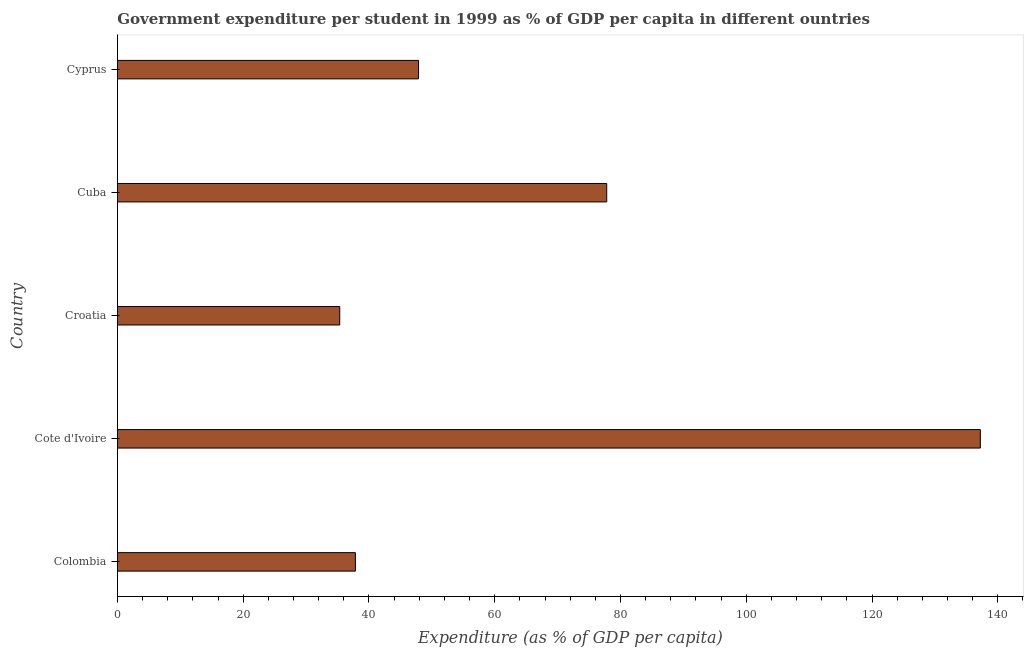Does the graph contain any zero values?
Make the answer very short. No. What is the title of the graph?
Keep it short and to the point. Government expenditure per student in 1999 as % of GDP per capita in different ountries. What is the label or title of the X-axis?
Ensure brevity in your answer.  Expenditure (as % of GDP per capita). What is the label or title of the Y-axis?
Give a very brief answer. Country. What is the government expenditure per student in Cyprus?
Give a very brief answer. 47.88. Across all countries, what is the maximum government expenditure per student?
Give a very brief answer. 137.22. Across all countries, what is the minimum government expenditure per student?
Provide a short and direct response. 35.35. In which country was the government expenditure per student maximum?
Give a very brief answer. Cote d'Ivoire. In which country was the government expenditure per student minimum?
Keep it short and to the point. Croatia. What is the sum of the government expenditure per student?
Your answer should be very brief. 336.11. What is the difference between the government expenditure per student in Colombia and Cote d'Ivoire?
Offer a terse response. -99.37. What is the average government expenditure per student per country?
Offer a very short reply. 67.22. What is the median government expenditure per student?
Make the answer very short. 47.88. What is the ratio of the government expenditure per student in Colombia to that in Cote d'Ivoire?
Ensure brevity in your answer.  0.28. Is the difference between the government expenditure per student in Colombia and Cuba greater than the difference between any two countries?
Keep it short and to the point. No. What is the difference between the highest and the second highest government expenditure per student?
Offer a terse response. 59.41. Is the sum of the government expenditure per student in Croatia and Cuba greater than the maximum government expenditure per student across all countries?
Make the answer very short. No. What is the difference between the highest and the lowest government expenditure per student?
Keep it short and to the point. 101.87. How many bars are there?
Keep it short and to the point. 5. Are all the bars in the graph horizontal?
Offer a terse response. Yes. Are the values on the major ticks of X-axis written in scientific E-notation?
Offer a terse response. No. What is the Expenditure (as % of GDP per capita) of Colombia?
Make the answer very short. 37.85. What is the Expenditure (as % of GDP per capita) of Cote d'Ivoire?
Your response must be concise. 137.22. What is the Expenditure (as % of GDP per capita) of Croatia?
Give a very brief answer. 35.35. What is the Expenditure (as % of GDP per capita) of Cuba?
Make the answer very short. 77.81. What is the Expenditure (as % of GDP per capita) of Cyprus?
Give a very brief answer. 47.88. What is the difference between the Expenditure (as % of GDP per capita) in Colombia and Cote d'Ivoire?
Give a very brief answer. -99.37. What is the difference between the Expenditure (as % of GDP per capita) in Colombia and Croatia?
Your answer should be very brief. 2.5. What is the difference between the Expenditure (as % of GDP per capita) in Colombia and Cuba?
Give a very brief answer. -39.96. What is the difference between the Expenditure (as % of GDP per capita) in Colombia and Cyprus?
Offer a very short reply. -10.04. What is the difference between the Expenditure (as % of GDP per capita) in Cote d'Ivoire and Croatia?
Your answer should be compact. 101.87. What is the difference between the Expenditure (as % of GDP per capita) in Cote d'Ivoire and Cuba?
Offer a terse response. 59.41. What is the difference between the Expenditure (as % of GDP per capita) in Cote d'Ivoire and Cyprus?
Offer a terse response. 89.34. What is the difference between the Expenditure (as % of GDP per capita) in Croatia and Cuba?
Offer a terse response. -42.46. What is the difference between the Expenditure (as % of GDP per capita) in Croatia and Cyprus?
Your answer should be compact. -12.53. What is the difference between the Expenditure (as % of GDP per capita) in Cuba and Cyprus?
Your response must be concise. 29.92. What is the ratio of the Expenditure (as % of GDP per capita) in Colombia to that in Cote d'Ivoire?
Your answer should be very brief. 0.28. What is the ratio of the Expenditure (as % of GDP per capita) in Colombia to that in Croatia?
Ensure brevity in your answer.  1.07. What is the ratio of the Expenditure (as % of GDP per capita) in Colombia to that in Cuba?
Ensure brevity in your answer.  0.49. What is the ratio of the Expenditure (as % of GDP per capita) in Colombia to that in Cyprus?
Your answer should be very brief. 0.79. What is the ratio of the Expenditure (as % of GDP per capita) in Cote d'Ivoire to that in Croatia?
Provide a succinct answer. 3.88. What is the ratio of the Expenditure (as % of GDP per capita) in Cote d'Ivoire to that in Cuba?
Your answer should be very brief. 1.76. What is the ratio of the Expenditure (as % of GDP per capita) in Cote d'Ivoire to that in Cyprus?
Provide a short and direct response. 2.87. What is the ratio of the Expenditure (as % of GDP per capita) in Croatia to that in Cuba?
Offer a very short reply. 0.45. What is the ratio of the Expenditure (as % of GDP per capita) in Croatia to that in Cyprus?
Offer a terse response. 0.74. What is the ratio of the Expenditure (as % of GDP per capita) in Cuba to that in Cyprus?
Keep it short and to the point. 1.62. 